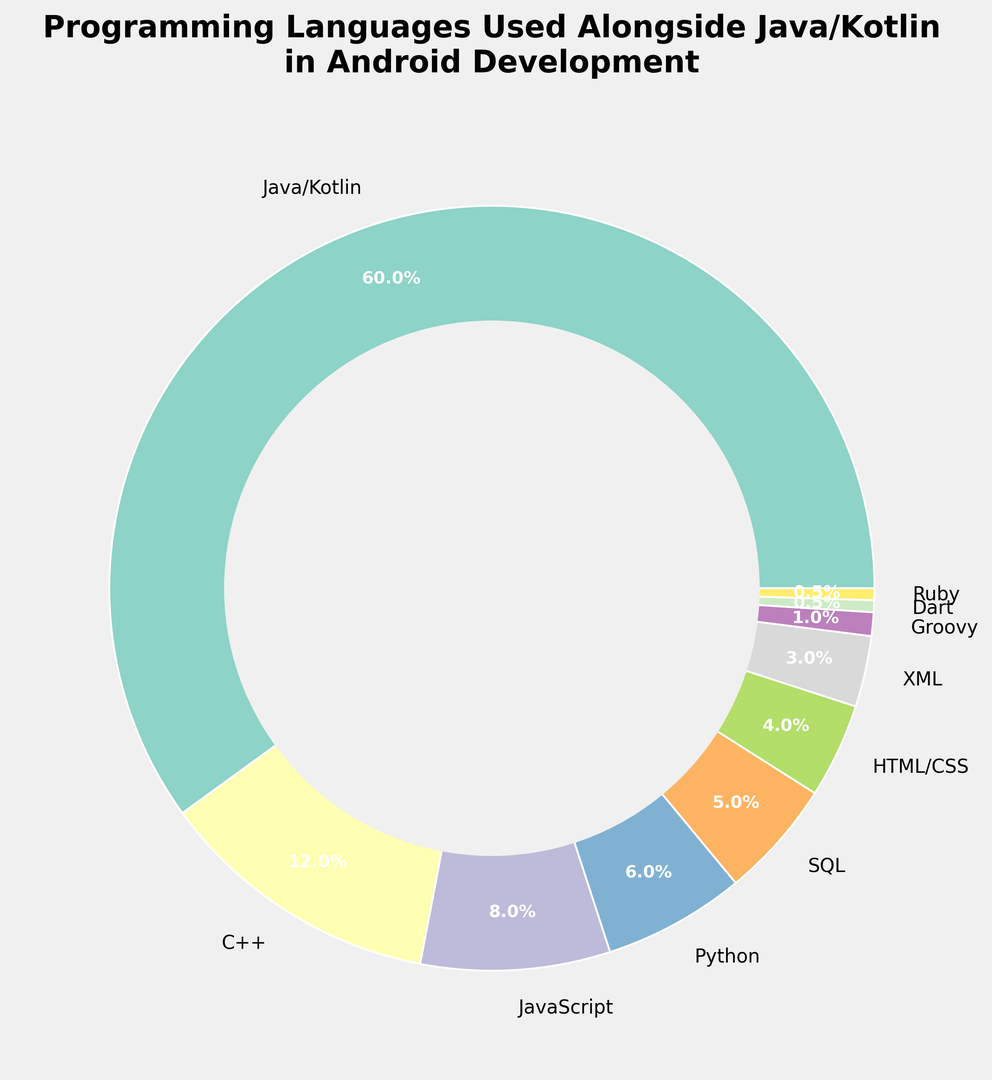What percentage of the pie chart does Python represent? Python represents 6% of the pie chart as labeled on the figure.
Answer: 6% How does the usage of C++ compare to that of JavaScript? C++ is used slightly more than JavaScript. The chart shows that C++ accounts for 12%, while JavaScript accounts for 8%.
Answer: C++ is greater What is the combined percentage of XML and Groovy? By adding the percentages labeled for XML (3%) and Groovy (1%), the total combined percentage for these two languages is 3% + 1% = 4%.
Answer: 4% Which language is used the least aside from Dart and Ruby? The chart shows that among Dart (0.5%) and Ruby (0.5%), the next least used language is Groovy at 1%.
Answer: Groovy What is the difference between the percentage of SQL and HTML/CSS? SQL is shown as 5% and HTML/CSS as 4%. The difference is 5% - 4% = 1%.
Answer: 1% Which language category makes up the majority of the chart? The segment labeled "Java/Kotlin" represents 60% of the chart, which is the majority.
Answer: Java/Kotlin What percentage of programming languages other than Java/Kotlin, C++, and JavaScript is used? The percentages for other languages are Python (6%), SQL (5%), HTML/CSS (4%), XML (3%), Groovy (1%), Dart (0.5%), and Ruby (0.5%). Adding these gives 6% + 5% + 4% + 3% + 1% + 0.5% + 0.5% = 20%.
Answer: 20% How much more is Java/Kotlin used compared to SQL? Java/Kotlin is used 60%, and SQL is used 5%. The difference is 60% - 5% = 55%.
Answer: 55% Which segment of the pie chart is represented in red? By visually inspecting the chart and the colors assigned to each segment, the "Python" segment (6%) is represented in red.
Answer: Python 